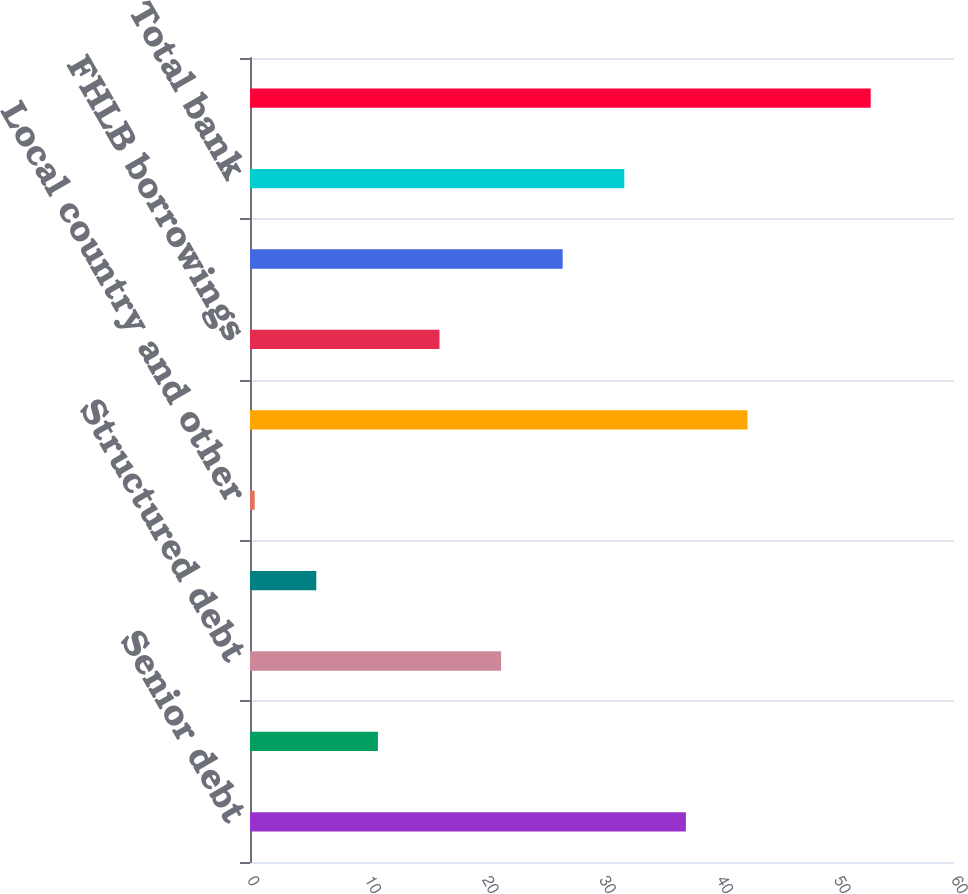Convert chart to OTSL. <chart><loc_0><loc_0><loc_500><loc_500><bar_chart><fcel>Senior debt<fcel>Subordinated debt<fcel>Structured debt<fcel>Non-structured debt<fcel>Local country and other<fcel>Total parent and other<fcel>FHLB borrowings<fcel>Securitizations<fcel>Total bank<fcel>Total<nl><fcel>37.15<fcel>10.9<fcel>21.4<fcel>5.65<fcel>0.4<fcel>42.4<fcel>16.15<fcel>26.65<fcel>31.9<fcel>52.9<nl></chart> 